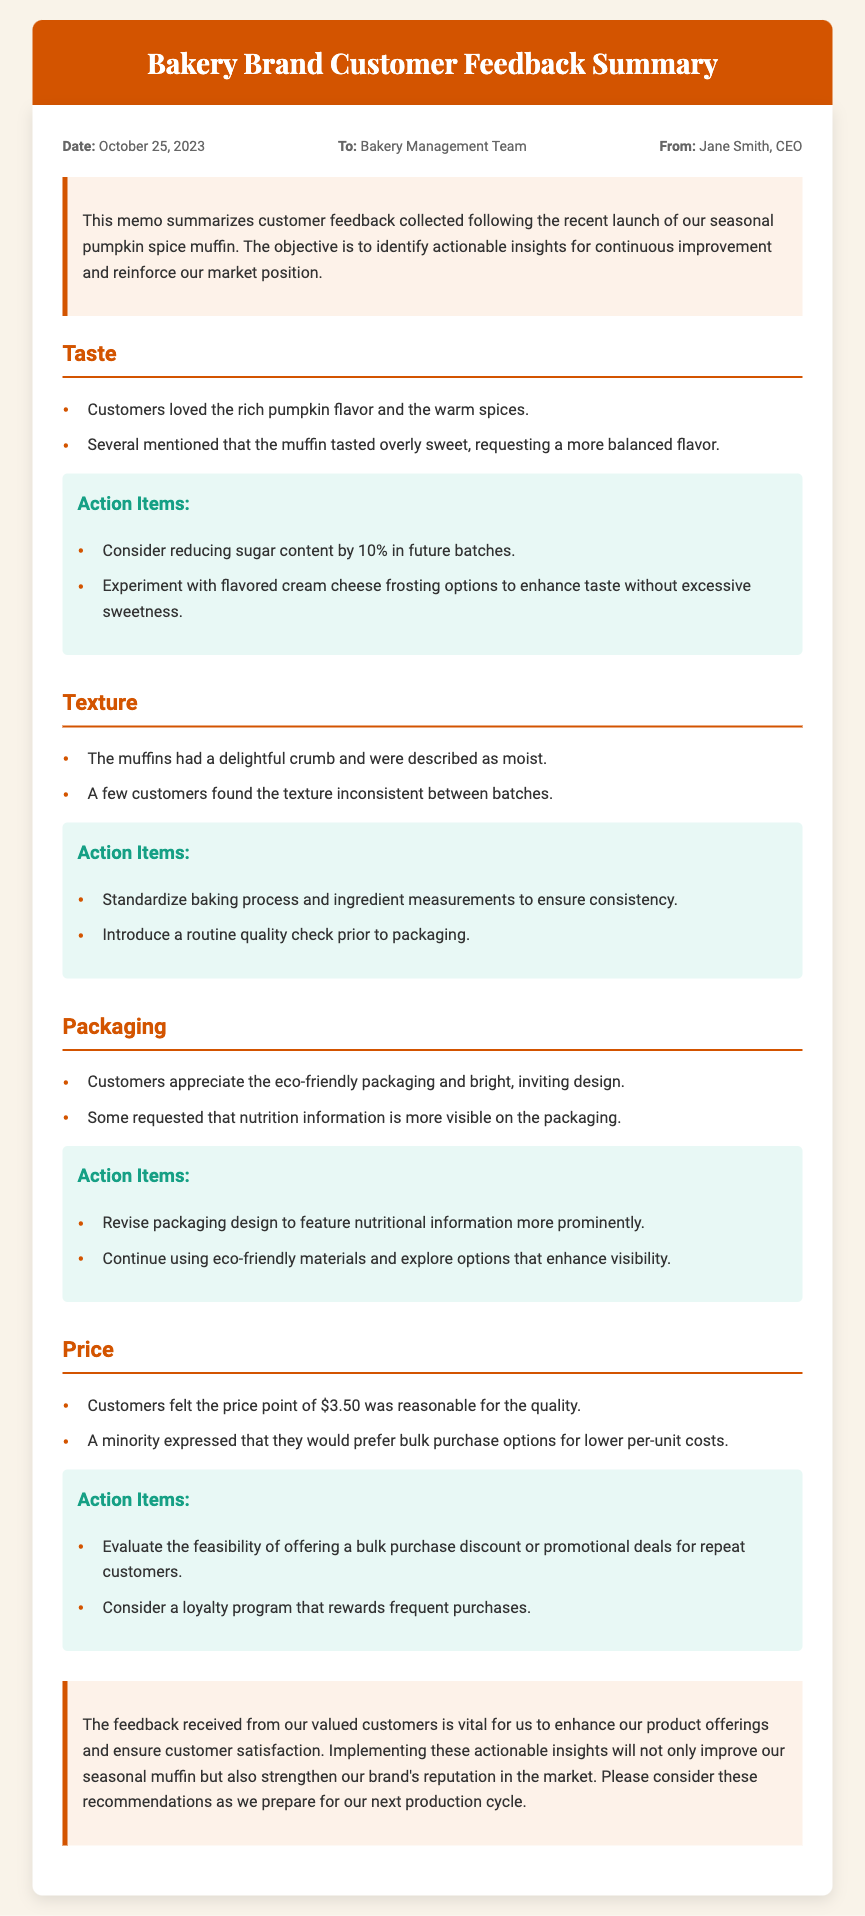What is the date of the memo? The date in the memo is clearly stated in the meta-info section.
Answer: October 25, 2023 Who is the author of the memo? The author is mentioned in the meta-info section at the top of the memo.
Answer: Jane Smith, CEO What specific flavor did customers love in the muffin? The memo mentions customer feedback about the taste of the muffin specifically highlighting one flavor.
Answer: Rich pumpkin flavor By what percentage should sugar content be reduced according to the action items? The action items suggest a specific percentage reduction of sugar content for future batches.
Answer: 10% What type of packaging is appreciated by customers? The feedback in the packaging section indicates customer preferences regarding packaging material and design.
Answer: Eco-friendly packaging What price did customers feel was reasonable for the muffin? The feedback provided in the price section includes the specific price point customers thought was acceptable.
Answer: $3.50 What is one action item suggested regarding the texture of the muffins? The action items related to texture highlight a specific measure to ensure consistency in muffins.
Answer: Standardize baking process What does the conclusion emphasize? The conclusion summarizes the main idea and importance conveyed in the memo about customer feedback.
Answer: Enhance product offerings What is a suggested bulk purchase option mentioned in the pricing feedback? The pricing section of the memo includes requests from customers regarding purchasing options.
Answer: Bulk purchase discount 